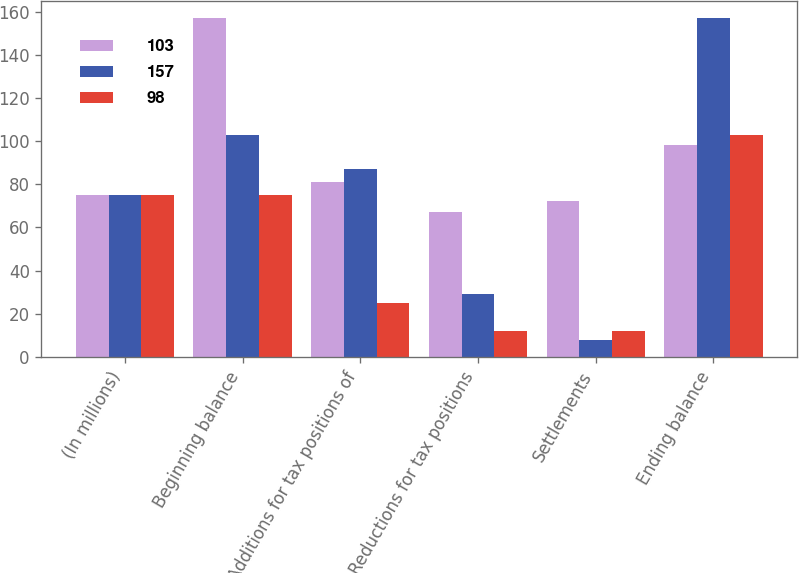Convert chart. <chart><loc_0><loc_0><loc_500><loc_500><stacked_bar_chart><ecel><fcel>(In millions)<fcel>Beginning balance<fcel>Additions for tax positions of<fcel>Reductions for tax positions<fcel>Settlements<fcel>Ending balance<nl><fcel>103<fcel>75<fcel>157<fcel>81<fcel>67<fcel>72<fcel>98<nl><fcel>157<fcel>75<fcel>103<fcel>87<fcel>29<fcel>8<fcel>157<nl><fcel>98<fcel>75<fcel>75<fcel>25<fcel>12<fcel>12<fcel>103<nl></chart> 